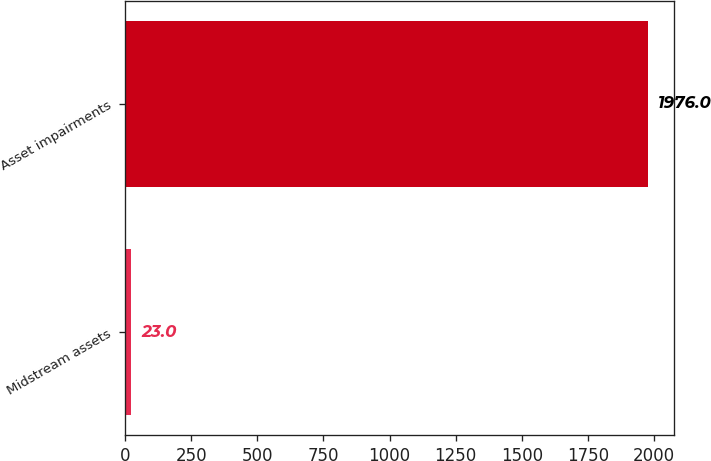<chart> <loc_0><loc_0><loc_500><loc_500><bar_chart><fcel>Midstream assets<fcel>Asset impairments<nl><fcel>23<fcel>1976<nl></chart> 